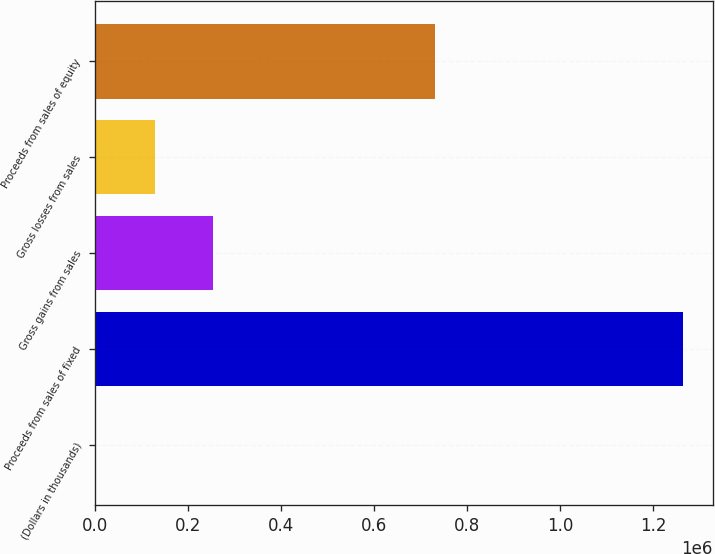Convert chart. <chart><loc_0><loc_0><loc_500><loc_500><bar_chart><fcel>(Dollars in thousands)<fcel>Proceeds from sales of fixed<fcel>Gross gains from sales<fcel>Gross losses from sales<fcel>Proceeds from sales of equity<nl><fcel>2016<fcel>1.26427e+06<fcel>254467<fcel>128242<fcel>729782<nl></chart> 